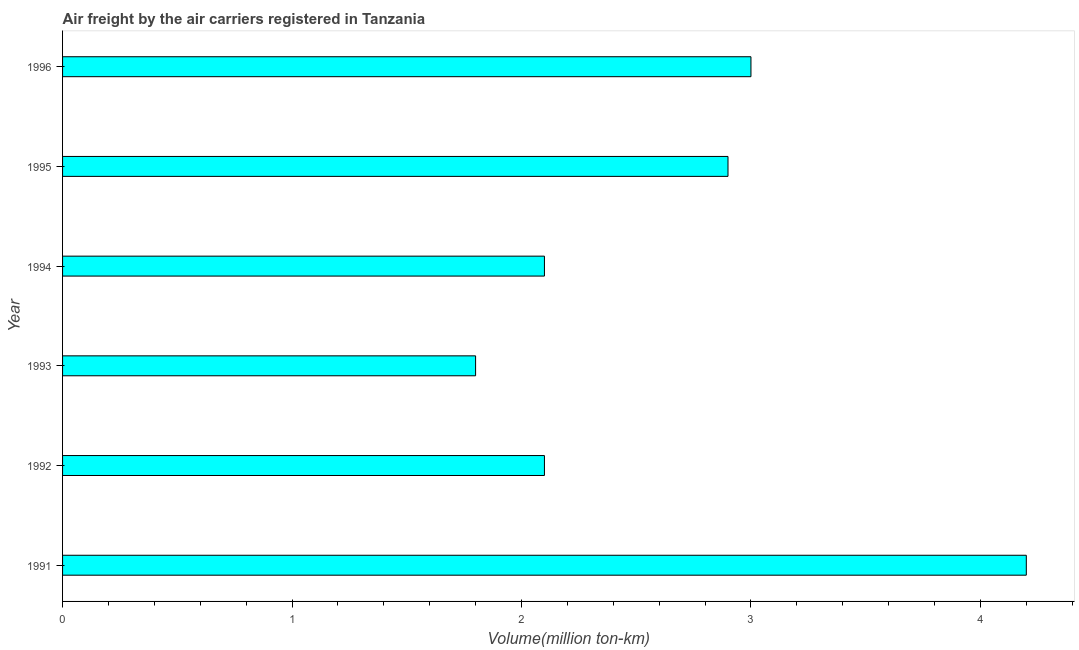Does the graph contain any zero values?
Keep it short and to the point. No. What is the title of the graph?
Your answer should be compact. Air freight by the air carriers registered in Tanzania. What is the label or title of the X-axis?
Make the answer very short. Volume(million ton-km). What is the air freight in 1994?
Your answer should be compact. 2.1. Across all years, what is the maximum air freight?
Make the answer very short. 4.2. Across all years, what is the minimum air freight?
Offer a terse response. 1.8. In which year was the air freight minimum?
Your response must be concise. 1993. What is the sum of the air freight?
Keep it short and to the point. 16.1. What is the difference between the air freight in 1991 and 1995?
Your answer should be compact. 1.3. What is the average air freight per year?
Offer a terse response. 2.68. What is the median air freight?
Provide a short and direct response. 2.5. What is the ratio of the air freight in 1994 to that in 1995?
Provide a succinct answer. 0.72. Is the air freight in 1991 less than that in 1995?
Ensure brevity in your answer.  No. Is the difference between the air freight in 1993 and 1996 greater than the difference between any two years?
Keep it short and to the point. No. What is the difference between the highest and the second highest air freight?
Your answer should be compact. 1.2. Is the sum of the air freight in 1991 and 1992 greater than the maximum air freight across all years?
Offer a terse response. Yes. How many bars are there?
Keep it short and to the point. 6. How many years are there in the graph?
Your answer should be compact. 6. Are the values on the major ticks of X-axis written in scientific E-notation?
Offer a terse response. No. What is the Volume(million ton-km) in 1991?
Your response must be concise. 4.2. What is the Volume(million ton-km) of 1992?
Give a very brief answer. 2.1. What is the Volume(million ton-km) of 1993?
Provide a short and direct response. 1.8. What is the Volume(million ton-km) in 1994?
Offer a terse response. 2.1. What is the Volume(million ton-km) in 1995?
Your answer should be compact. 2.9. What is the difference between the Volume(million ton-km) in 1991 and 1996?
Offer a terse response. 1.2. What is the difference between the Volume(million ton-km) in 1992 and 1993?
Offer a terse response. 0.3. What is the difference between the Volume(million ton-km) in 1992 and 1994?
Keep it short and to the point. 0. What is the difference between the Volume(million ton-km) in 1992 and 1995?
Give a very brief answer. -0.8. What is the difference between the Volume(million ton-km) in 1994 and 1995?
Provide a succinct answer. -0.8. What is the difference between the Volume(million ton-km) in 1994 and 1996?
Give a very brief answer. -0.9. What is the ratio of the Volume(million ton-km) in 1991 to that in 1993?
Provide a short and direct response. 2.33. What is the ratio of the Volume(million ton-km) in 1991 to that in 1994?
Your answer should be very brief. 2. What is the ratio of the Volume(million ton-km) in 1991 to that in 1995?
Provide a short and direct response. 1.45. What is the ratio of the Volume(million ton-km) in 1991 to that in 1996?
Your response must be concise. 1.4. What is the ratio of the Volume(million ton-km) in 1992 to that in 1993?
Your response must be concise. 1.17. What is the ratio of the Volume(million ton-km) in 1992 to that in 1994?
Keep it short and to the point. 1. What is the ratio of the Volume(million ton-km) in 1992 to that in 1995?
Your response must be concise. 0.72. What is the ratio of the Volume(million ton-km) in 1992 to that in 1996?
Your answer should be very brief. 0.7. What is the ratio of the Volume(million ton-km) in 1993 to that in 1994?
Offer a very short reply. 0.86. What is the ratio of the Volume(million ton-km) in 1993 to that in 1995?
Make the answer very short. 0.62. What is the ratio of the Volume(million ton-km) in 1993 to that in 1996?
Keep it short and to the point. 0.6. What is the ratio of the Volume(million ton-km) in 1994 to that in 1995?
Ensure brevity in your answer.  0.72. 